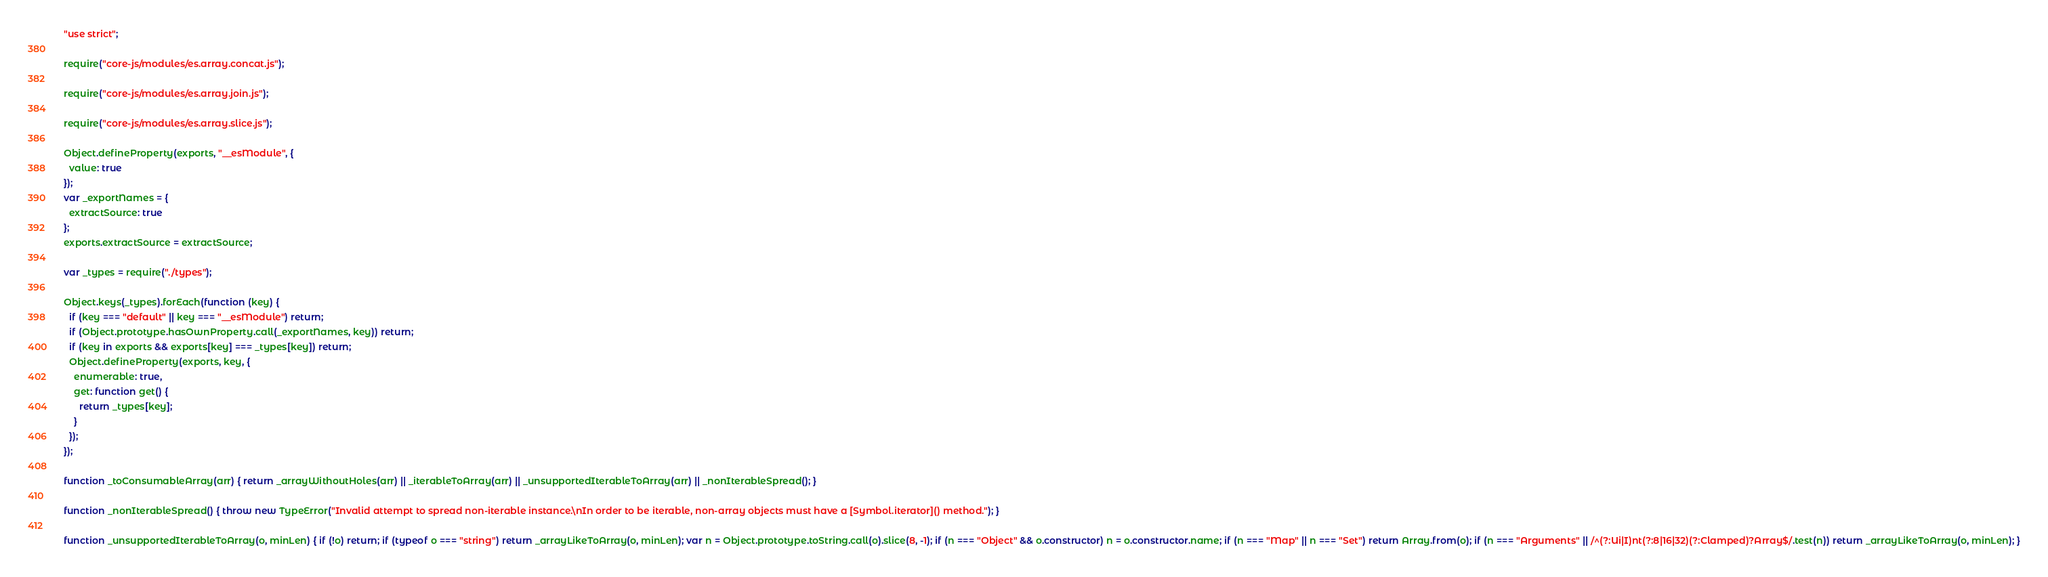<code> <loc_0><loc_0><loc_500><loc_500><_JavaScript_>"use strict";

require("core-js/modules/es.array.concat.js");

require("core-js/modules/es.array.join.js");

require("core-js/modules/es.array.slice.js");

Object.defineProperty(exports, "__esModule", {
  value: true
});
var _exportNames = {
  extractSource: true
};
exports.extractSource = extractSource;

var _types = require("./types");

Object.keys(_types).forEach(function (key) {
  if (key === "default" || key === "__esModule") return;
  if (Object.prototype.hasOwnProperty.call(_exportNames, key)) return;
  if (key in exports && exports[key] === _types[key]) return;
  Object.defineProperty(exports, key, {
    enumerable: true,
    get: function get() {
      return _types[key];
    }
  });
});

function _toConsumableArray(arr) { return _arrayWithoutHoles(arr) || _iterableToArray(arr) || _unsupportedIterableToArray(arr) || _nonIterableSpread(); }

function _nonIterableSpread() { throw new TypeError("Invalid attempt to spread non-iterable instance.\nIn order to be iterable, non-array objects must have a [Symbol.iterator]() method."); }

function _unsupportedIterableToArray(o, minLen) { if (!o) return; if (typeof o === "string") return _arrayLikeToArray(o, minLen); var n = Object.prototype.toString.call(o).slice(8, -1); if (n === "Object" && o.constructor) n = o.constructor.name; if (n === "Map" || n === "Set") return Array.from(o); if (n === "Arguments" || /^(?:Ui|I)nt(?:8|16|32)(?:Clamped)?Array$/.test(n)) return _arrayLikeToArray(o, minLen); }
</code> 